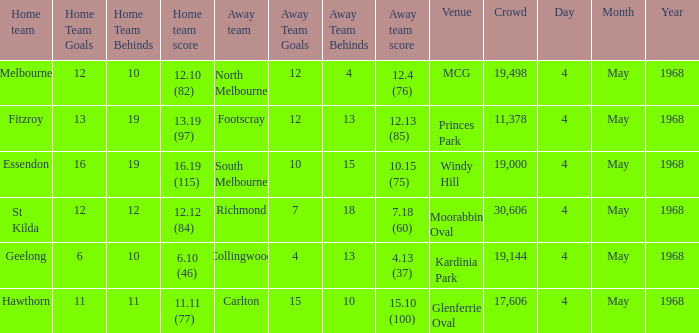What away team played at Kardinia Park? 4.13 (37). 